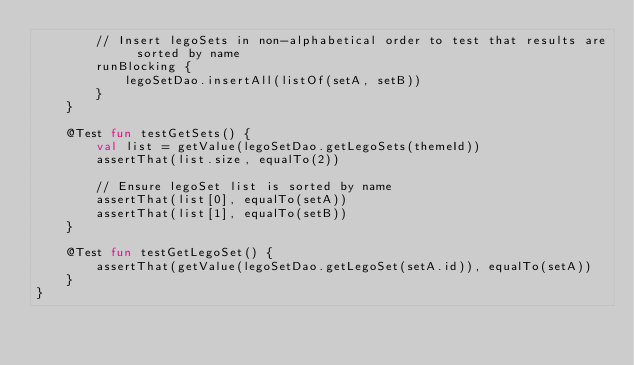<code> <loc_0><loc_0><loc_500><loc_500><_Kotlin_>        // Insert legoSets in non-alphabetical order to test that results are sorted by name
        runBlocking {
            legoSetDao.insertAll(listOf(setA, setB))
        }
    }

    @Test fun testGetSets() {
        val list = getValue(legoSetDao.getLegoSets(themeId))
        assertThat(list.size, equalTo(2))

        // Ensure legoSet list is sorted by name
        assertThat(list[0], equalTo(setA))
        assertThat(list[1], equalTo(setB))
    }

    @Test fun testGetLegoSet() {
        assertThat(getValue(legoSetDao.getLegoSet(setA.id)), equalTo(setA))
    }
}</code> 